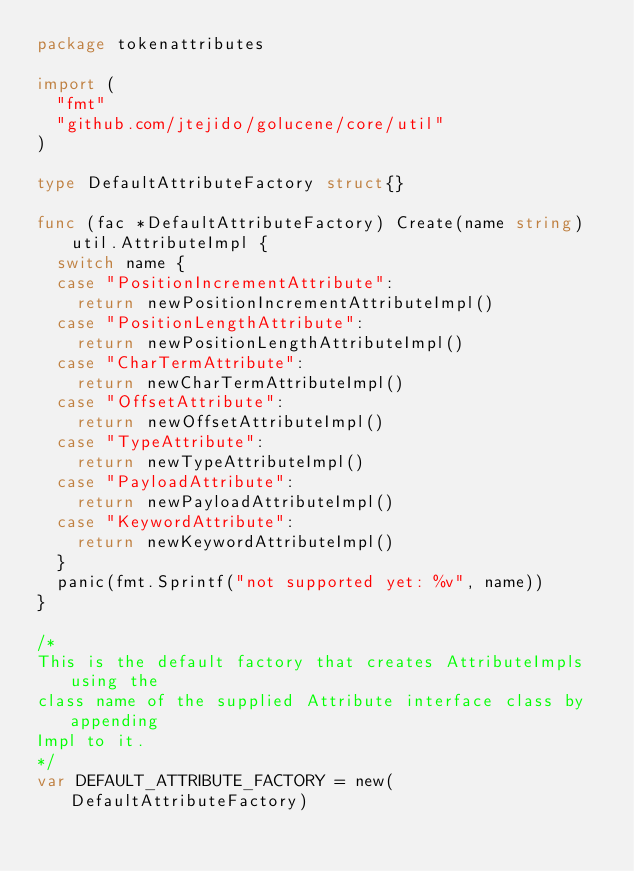<code> <loc_0><loc_0><loc_500><loc_500><_Go_>package tokenattributes

import (
	"fmt"
	"github.com/jtejido/golucene/core/util"
)

type DefaultAttributeFactory struct{}

func (fac *DefaultAttributeFactory) Create(name string) util.AttributeImpl {
	switch name {
	case "PositionIncrementAttribute":
		return newPositionIncrementAttributeImpl()
	case "PositionLengthAttribute":
		return newPositionLengthAttributeImpl()
	case "CharTermAttribute":
		return newCharTermAttributeImpl()
	case "OffsetAttribute":
		return newOffsetAttributeImpl()
	case "TypeAttribute":
		return newTypeAttributeImpl()
	case "PayloadAttribute":
		return newPayloadAttributeImpl()
	case "KeywordAttribute":
		return newKeywordAttributeImpl()
	}
	panic(fmt.Sprintf("not supported yet: %v", name))
}

/*
This is the default factory that creates AttributeImpls using the
class name of the supplied Attribute interface class by appending
Impl to it.
*/
var DEFAULT_ATTRIBUTE_FACTORY = new(DefaultAttributeFactory)
</code> 